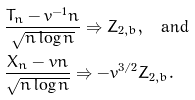<formula> <loc_0><loc_0><loc_500><loc_500>& \frac { T _ { n } - v ^ { - 1 } n } { \sqrt { n \log n } } \Rightarrow Z _ { 2 , b } , \quad \text {and} \\ & \frac { X _ { n } - v n } { \sqrt { n \log n } } \Rightarrow - v ^ { 3 / 2 } Z _ { 2 , b } .</formula> 